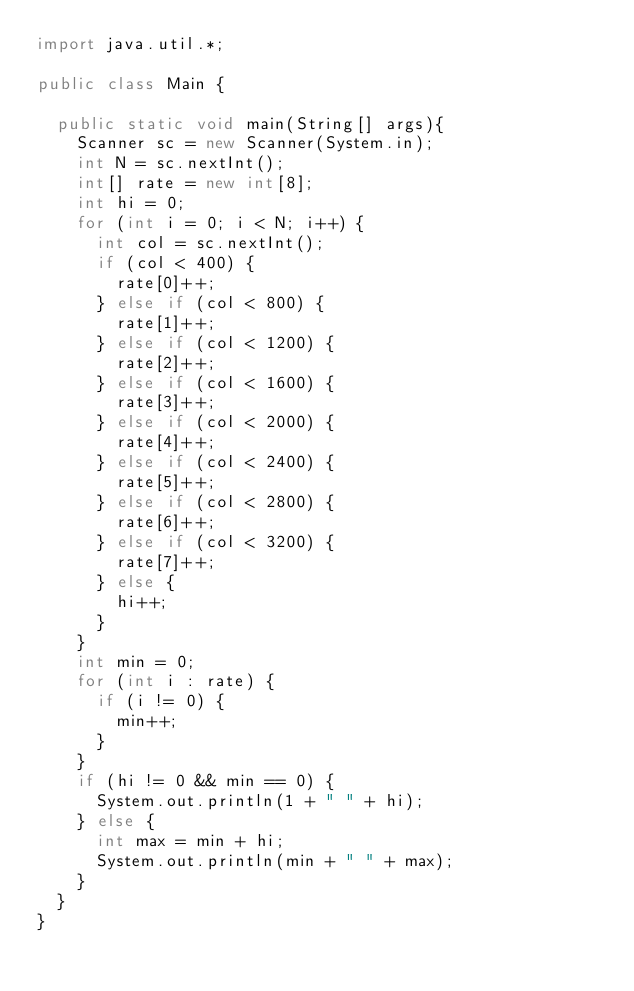<code> <loc_0><loc_0><loc_500><loc_500><_Java_>import java.util.*;
 
public class Main {
 
	public static void main(String[] args){
		Scanner sc = new Scanner(System.in);
		int N = sc.nextInt();
		int[] rate = new int[8];
		int hi = 0;
		for (int i = 0; i < N; i++) {
			int col = sc.nextInt();
			if (col < 400) {
				rate[0]++;
			} else if (col < 800) {
				rate[1]++;
			} else if (col < 1200) {
				rate[2]++;
			} else if (col < 1600) {
				rate[3]++;
			} else if (col < 2000) {
				rate[4]++;
			} else if (col < 2400) {
				rate[5]++;
			} else if (col < 2800) {
				rate[6]++;
			} else if (col < 3200) {
				rate[7]++;
			} else {
				hi++;
			}
		}
		int min = 0;
		for (int i : rate) {
			if (i != 0) {
				min++;
			}
		}
		if (hi != 0 && min == 0) {
			System.out.println(1 + " " + hi);
		} else {
			int max = min + hi;
			System.out.println(min + " " + max);
		}
	}
}</code> 